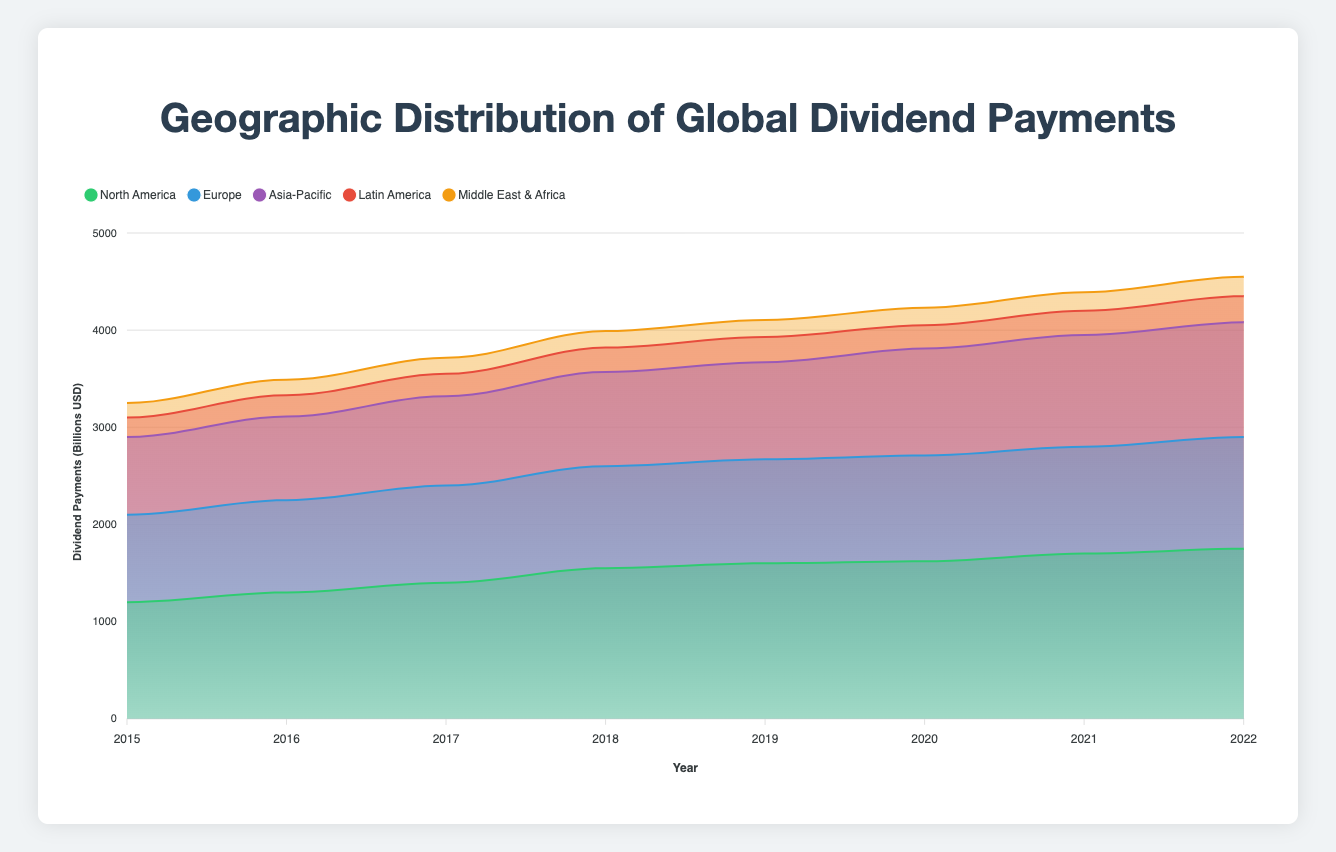What is the title of the chart? The title of the chart is displayed at the top center of the figure. Reading the title tells us what the chart is about.
Answer: Geographic Distribution of Global Dividend Payments Which region had the highest dividend payments in 2022? By looking at the stacked areas for each region in 2022, the area representing North America is the tallest. Therefore, North America had the highest dividend payments.
Answer: North America How did dividend payments for Europe change from 2015 to 2019? To find this, look at the height of the area representing Europe for the years 2015 and 2019. In 2015 it was 900 billion and in 2019 it was 1070 billion. This shows an increase of 170 billion.
Answer: Increased by 170 billion USD What is the total dividend payment for all regions combined in 2020? Add the dividend payments for each region in 2020: 1620 (NA) + 1090 (EU) + 1100 (APAC) + 240 (LA) + 180 (MEA) = 4230 billion USD.
Answer: 4230 billion USD Which region had the least variation in its dividend payments from 2015 to 2022? Calculate the difference between the highest and lowest values for each region. North America (550), Europe (250), Asia-Pacific (380), Latin America (70), Middle East & Africa (50). The smallest difference is seen in Middle East & Africa.
Answer: Middle East & Africa Compare the dividend payments of Asia-Pacific and Europe in 2022. Which is higher, and by how much? Asia-Pacific had 1180 billion and Europe had 1150 billion in 2022. The difference between them is 1180 - 1150 = 30 billion. Asia-Pacific is higher by 30 billion.
Answer: Asia-Pacific, 30 billion Is there a year where all regions collectively had an increase in dividend payments compared to the previous year? Compare each year to the prior year for all regions. Between 2016 and 2017, all regions had an increase: North America (100), Europe (50), Asia-Pacific (60), Latin America (10), Middle East & Africa (5).
Answer: 2016 to 2017 Describe the trend of dividend payments in North America from 2015 to 2022. Observing the area for North America, there is a steady increase from 1200 billion in 2015 to 1750 billion in 2022. The trend shows continuous growth over the period.
Answer: Steady increase What is the average annual dividend payment for Latin America from 2015 to 2022? To find the average, sum all payments from 2015 to 2022 (200 + 220 + 230 + 250 + 260 + 240 + 250 + 270 = 1920) and divide by the number of years (1920/8 = 240).
Answer: 240 billion USD How did the dividend payments of Middle East & Africa change from 2019 to 2020? Comparing the payments in 2019 (175 billion) and 2020 (180 billion), the difference is an increase of 5 billion.
Answer: Increased by 5 billion USD 